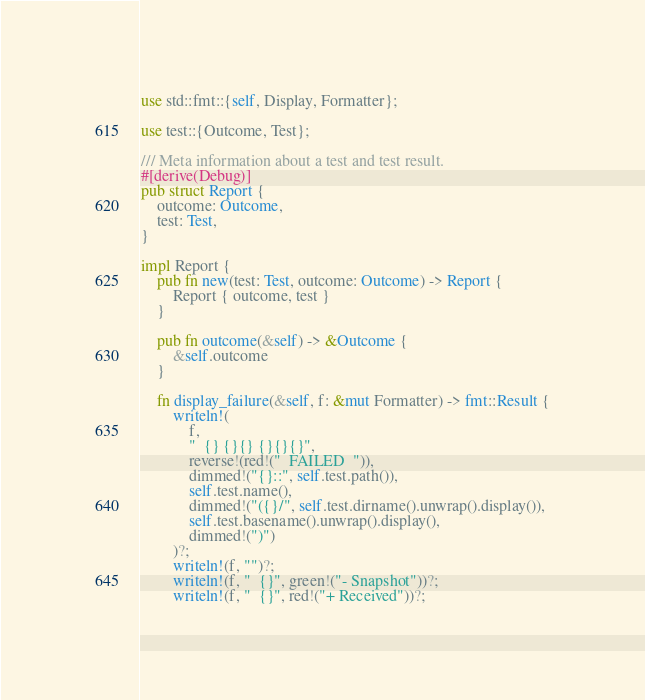Convert code to text. <code><loc_0><loc_0><loc_500><loc_500><_Rust_>use std::fmt::{self, Display, Formatter};

use test::{Outcome, Test};

/// Meta information about a test and test result.
#[derive(Debug)]
pub struct Report {
    outcome: Outcome,
    test: Test,
}

impl Report {
    pub fn new(test: Test, outcome: Outcome) -> Report {
        Report { outcome, test }
    }

    pub fn outcome(&self) -> &Outcome {
        &self.outcome
    }

    fn display_failure(&self, f: &mut Formatter) -> fmt::Result {
        writeln!(
            f,
            "  {} {}{} {}{}{}",
            reverse!(red!("  FAILED  ")),
            dimmed!("{}::", self.test.path()),
            self.test.name(),
            dimmed!("({}/", self.test.dirname().unwrap().display()),
            self.test.basename().unwrap().display(),
            dimmed!(")")
        )?;
        writeln!(f, "")?;
        writeln!(f, "  {}", green!("- Snapshot"))?;
        writeln!(f, "  {}", red!("+ Received"))?;</code> 